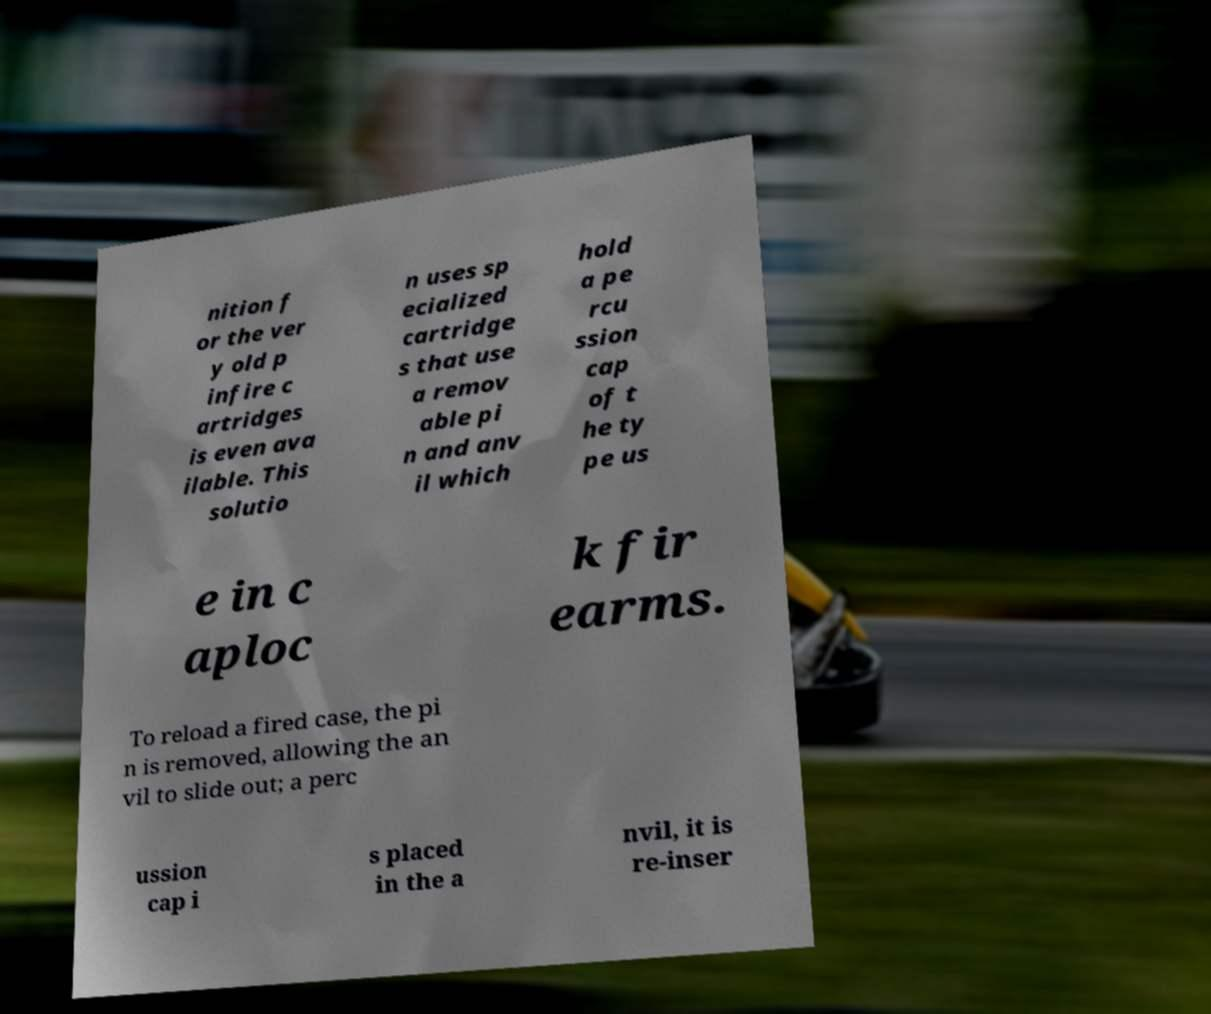I need the written content from this picture converted into text. Can you do that? nition f or the ver y old p infire c artridges is even ava ilable. This solutio n uses sp ecialized cartridge s that use a remov able pi n and anv il which hold a pe rcu ssion cap of t he ty pe us e in c aploc k fir earms. To reload a fired case, the pi n is removed, allowing the an vil to slide out; a perc ussion cap i s placed in the a nvil, it is re-inser 